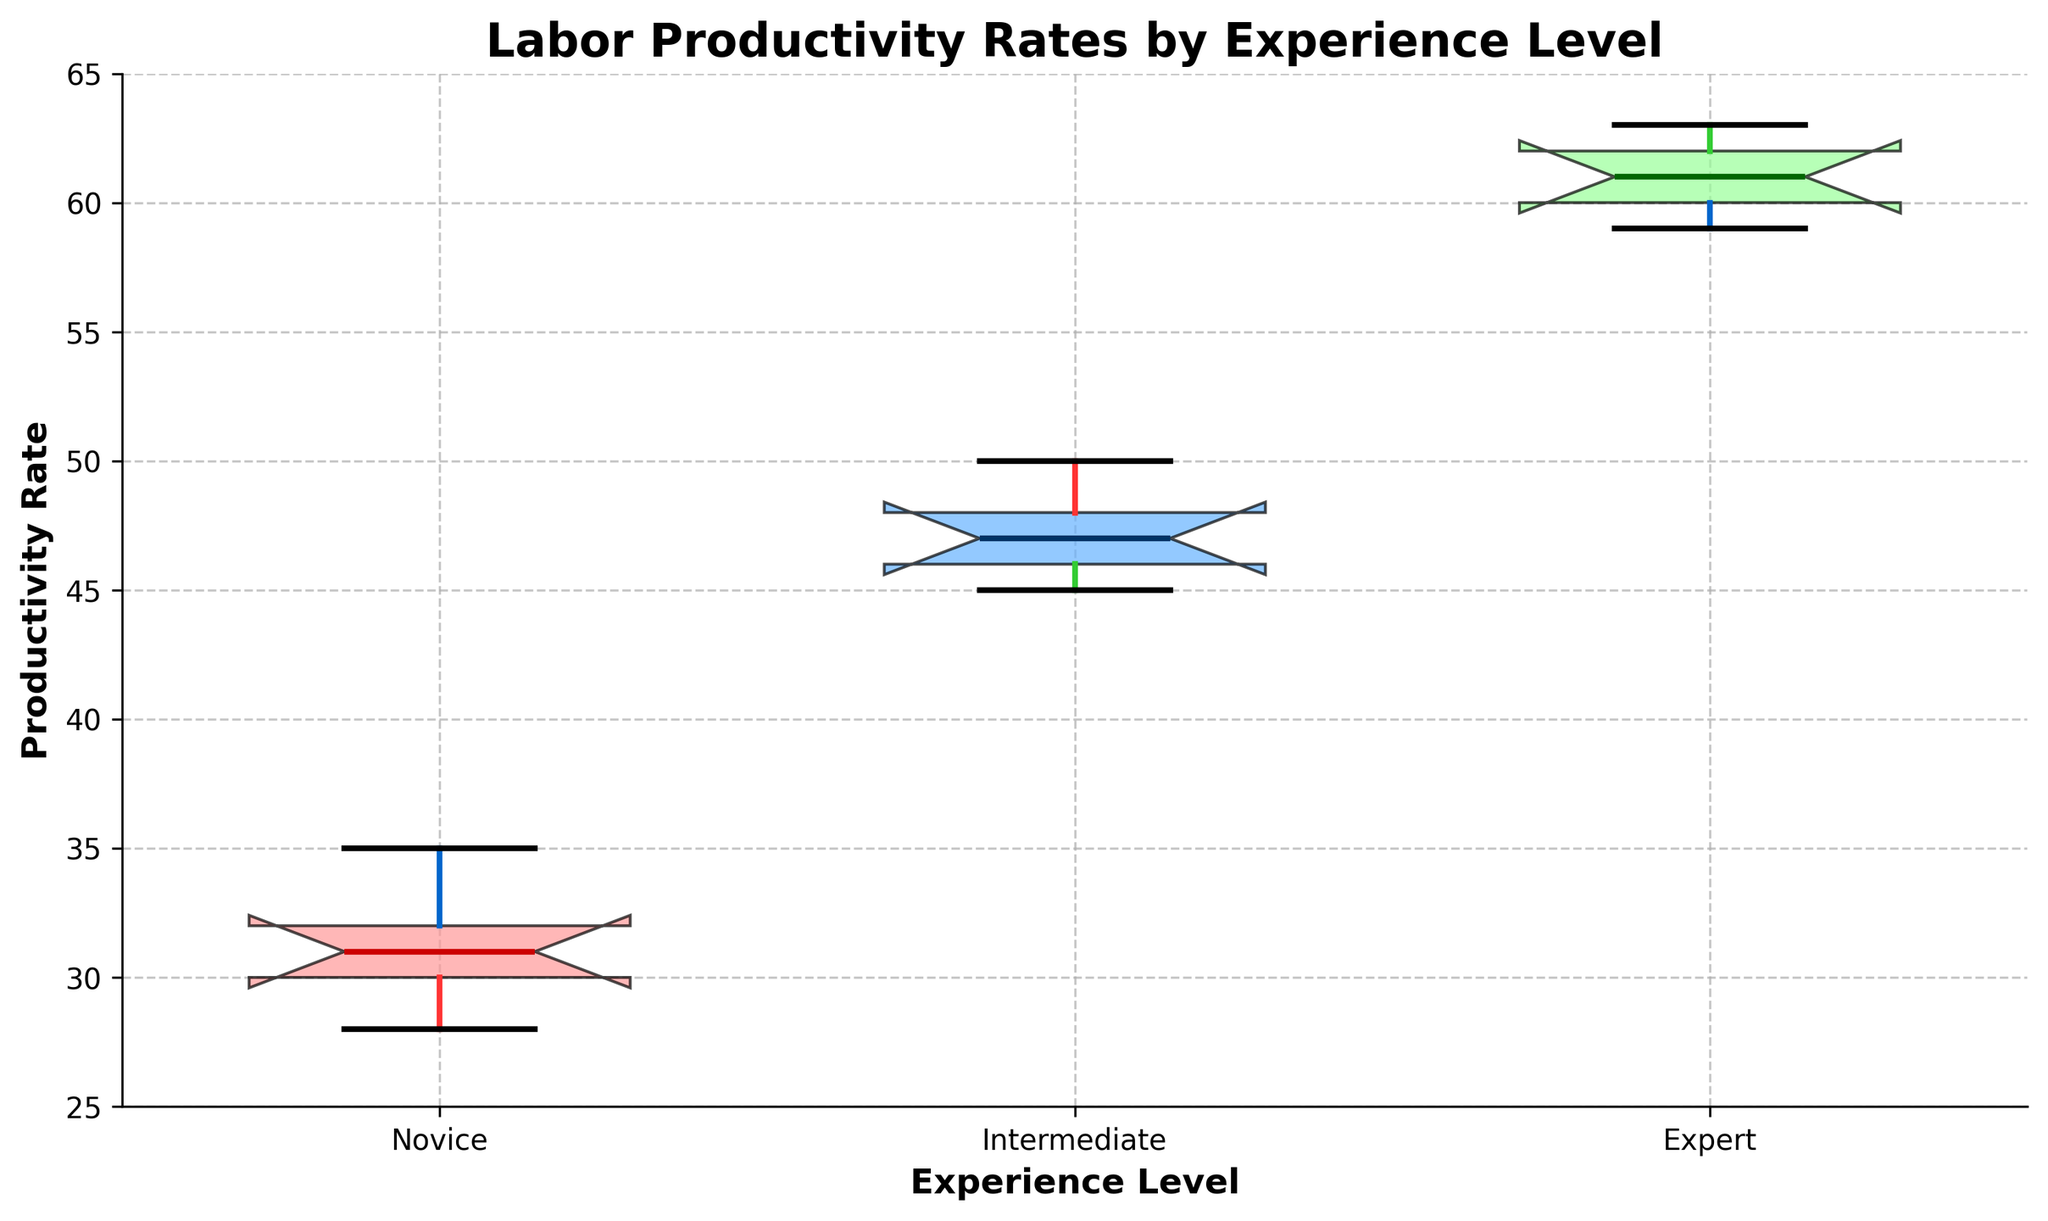What is the title of the plot? The title of the plot is displayed at the top center of the figure, which reads "Labor Productivity Rates by Experience Level".
Answer: Labor Productivity Rates by Experience Level What are the three experience levels shown on the X-axis? The three experience levels along the X-axis of the plot are labeled "Novice", "Intermediate", and "Expert".
Answer: Novice, Intermediate, Expert What color is used to fill the box for "Intermediate" experience level? The box for the "Intermediate" experience level is filled with a light blue color.
Answer: Light blue Which experience level has the highest median productivity rate? The median productivity rate is marked by a horizontal line within each box, and the "Expert" level box has the highest such line.
Answer: Expert What is the range of productivity rates for Novice workers? The range of productivity rates for Novice workers is denoted by the distance between the bottom whisker and the top whisker of the box plot for the Novice level, from 28 to 35.
Answer: 28–35 Which experience level shows the widest interquartile range (IQR)? The interquartile range (IQR) is represented by the height of the boxes. The "Intermediate" level has the widest box, indicating the largest IQR.
Answer: Intermediate How does the median productivity rate for Intermediate workers compare to Novice workers? The median productivity rate for Intermediate workers is higher than that for Novice workers, indicated by the higher median line in the Intermediate box compared to the Novice box.
Answer: Higher By how much does the upper whisker of the "Expert" level exceed the upper whisker of the "Novice" level? The upper whisker of the "Expert" level is at 63, while the upper whisker of the "Novice" level is at 35. The difference is 63 - 35 = 28.
Answer: 28 Is there any overlap in productivity rates between the Novice and Intermediate experience levels? The notches in the boxes show if there is a significant overlap in the medians. There does not seem to be overlapping notches between the Novice and Intermediate levels, indicating no significant overlap.
Answer: No 